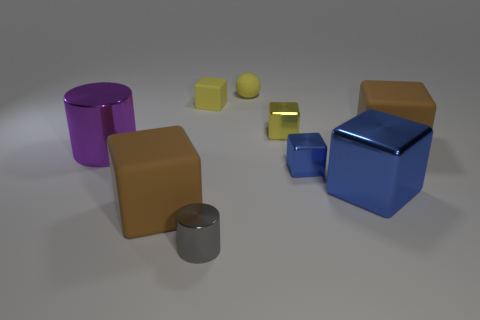Is the color of the big shiny cylinder the same as the small rubber ball?
Offer a very short reply. No. There is a object that is the same color as the big metal block; what is its shape?
Give a very brief answer. Cube. There is a shiny block that is the same color as the sphere; what is its size?
Your answer should be compact. Small. There is a small metal cube that is behind the big brown rubber block that is right of the brown cube that is on the left side of the small blue metallic block; what color is it?
Provide a short and direct response. Yellow. What is the shape of the tiny object that is behind the big blue metal thing and to the left of the small yellow matte ball?
Keep it short and to the point. Cube. What number of other things are the same shape as the gray thing?
Make the answer very short. 1. There is a big brown object that is behind the blue metal cube that is on the right side of the small cube in front of the purple thing; what shape is it?
Give a very brief answer. Cube. What number of things are either large metallic things or big blocks that are behind the big blue block?
Your response must be concise. 3. There is a tiny thing to the left of the tiny cylinder; does it have the same shape as the large brown rubber object to the right of the tiny gray metal thing?
Your response must be concise. Yes. How many objects are big brown objects or tiny yellow metal cubes?
Provide a succinct answer. 3. 